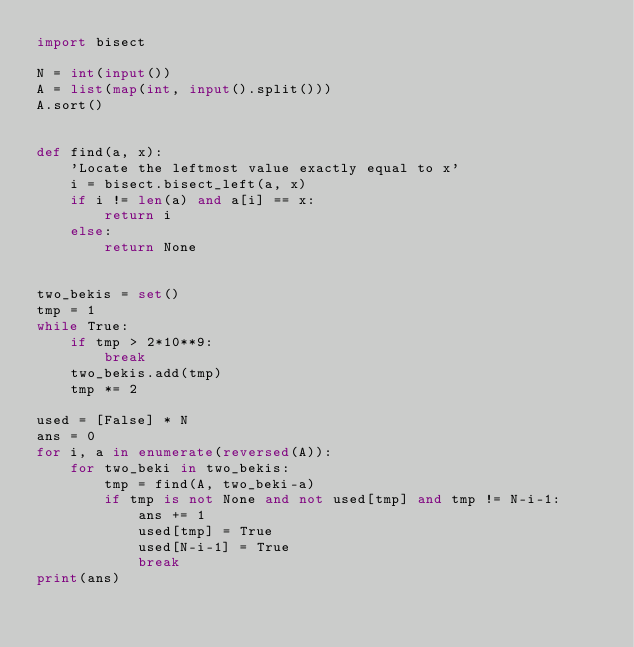Convert code to text. <code><loc_0><loc_0><loc_500><loc_500><_Python_>import bisect

N = int(input())
A = list(map(int, input().split()))
A.sort()


def find(a, x):
    'Locate the leftmost value exactly equal to x'
    i = bisect.bisect_left(a, x)
    if i != len(a) and a[i] == x:
        return i
    else:
        return None


two_bekis = set()
tmp = 1
while True:
    if tmp > 2*10**9:
        break
    two_bekis.add(tmp)
    tmp *= 2

used = [False] * N
ans = 0
for i, a in enumerate(reversed(A)):
    for two_beki in two_bekis:
        tmp = find(A, two_beki-a)
        if tmp is not None and not used[tmp] and tmp != N-i-1:
            ans += 1
            used[tmp] = True
            used[N-i-1] = True
            break
print(ans)
</code> 